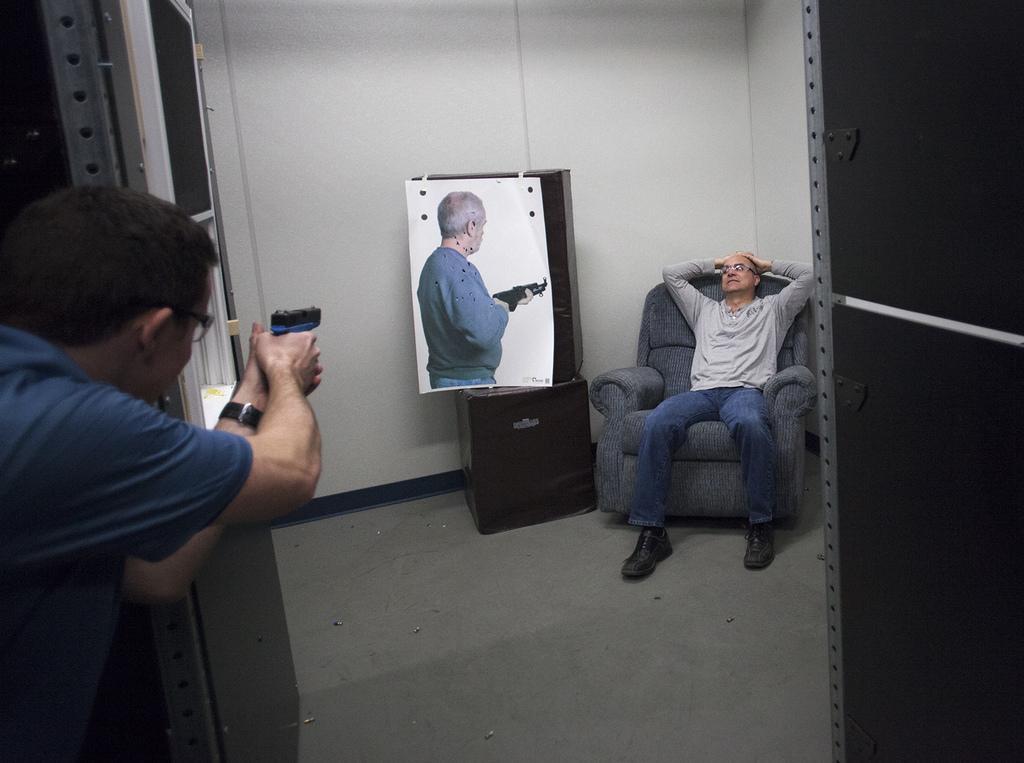Could you give a brief overview of what you see in this image? In the picture we can see a house inside it we can see a man sitting on the chair and beside him we can see a poster with a image of a man holding a gun and from the outside of the house we can see a man holding a gun and aiming at the poster. 